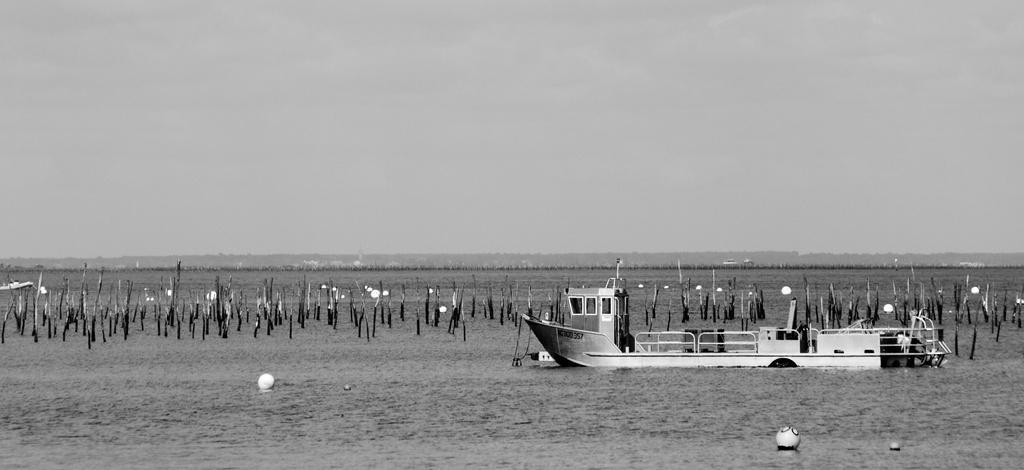How would you summarize this image in a sentence or two? In this image there are boats, wooden sticks and some other object in the water. In the background of the image there are mountains and sky. 